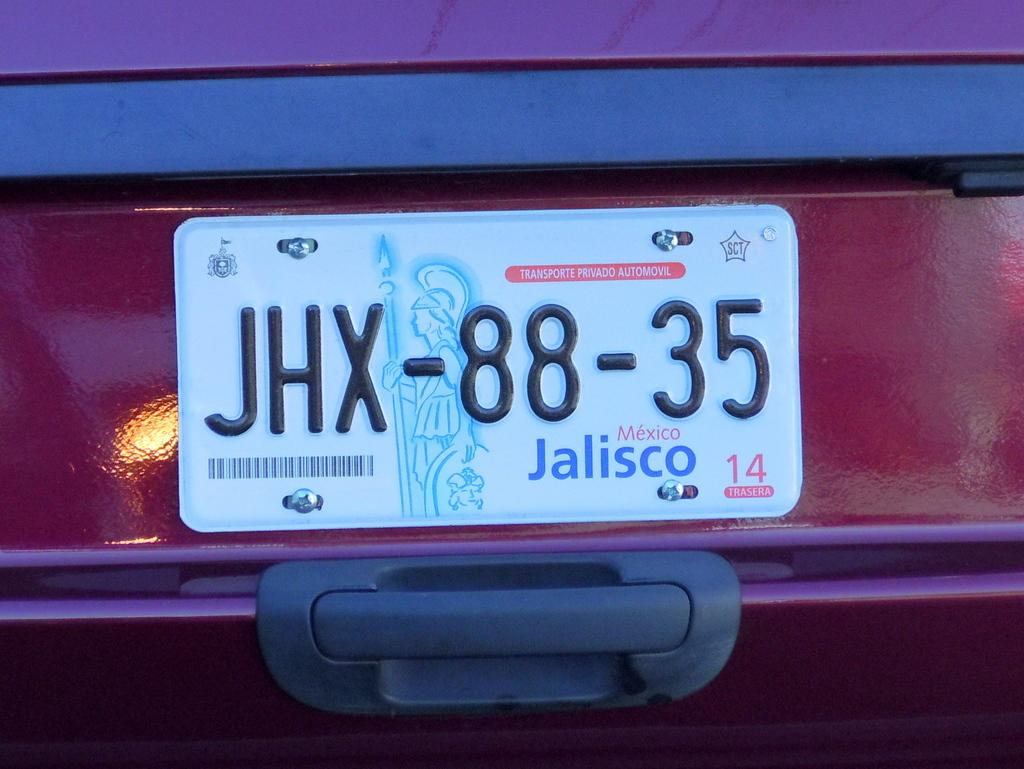What can be seen on the vehicle in the image? There is a number plate on a vehicle in the image. What religion is practiced by the cat in the image? There is no cat present in the image, and therefore no religious affiliation can be determined. 